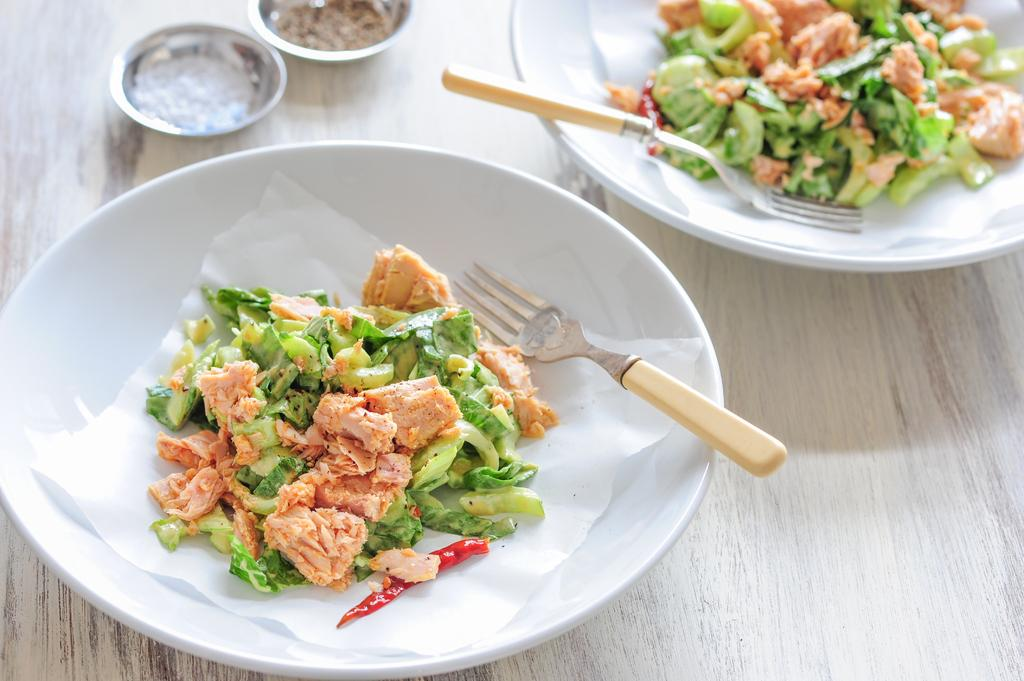What piece of furniture is present in the image? There is a table in the image. How many plates are on the table? There are two plates on the table. What is on the plates? The plates contain food items. How many bowls are on the table? There are two bowls on the table. What is in the bowls? The bowls contain something. What type of lead can be seen in the image? There is no lead present in the image. How many pails are visible in the image? There is no pail present in the image. 